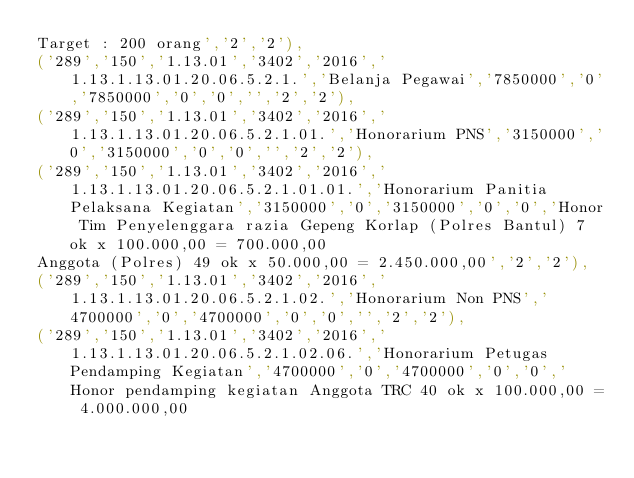Convert code to text. <code><loc_0><loc_0><loc_500><loc_500><_SQL_>Target : 200 orang','2','2'),
('289','150','1.13.01','3402','2016','1.13.1.13.01.20.06.5.2.1.','Belanja Pegawai','7850000','0','7850000','0','0','','2','2'),
('289','150','1.13.01','3402','2016','1.13.1.13.01.20.06.5.2.1.01.','Honorarium PNS','3150000','0','3150000','0','0','','2','2'),
('289','150','1.13.01','3402','2016','1.13.1.13.01.20.06.5.2.1.01.01.','Honorarium Panitia Pelaksana Kegiatan','3150000','0','3150000','0','0','Honor Tim Penyelenggara razia Gepeng Korlap (Polres Bantul) 7 ok x 100.000,00 = 700.000,00 
Anggota (Polres) 49 ok x 50.000,00 = 2.450.000,00','2','2'),
('289','150','1.13.01','3402','2016','1.13.1.13.01.20.06.5.2.1.02.','Honorarium Non PNS','4700000','0','4700000','0','0','','2','2'),
('289','150','1.13.01','3402','2016','1.13.1.13.01.20.06.5.2.1.02.06.','Honorarium Petugas Pendamping Kegiatan','4700000','0','4700000','0','0','Honor pendamping kegiatan Anggota TRC 40 ok x 100.000,00 = 4.000.000,00 </code> 